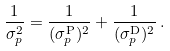Convert formula to latex. <formula><loc_0><loc_0><loc_500><loc_500>\frac { 1 } { \sigma _ { p } ^ { 2 } } = \frac { 1 } { ( \sigma _ { p } ^ { \text {P} } ) ^ { 2 } } + \frac { 1 } { ( \sigma _ { p } ^ { \text {D} } ) ^ { 2 } } \, .</formula> 